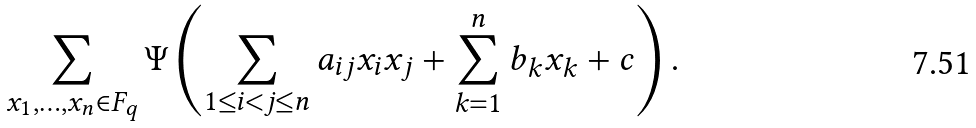<formula> <loc_0><loc_0><loc_500><loc_500>\sum _ { x _ { 1 } , \dots , x _ { n } \in { F } _ { q } } \Psi \left ( \sum _ { 1 \leq i < j \leq n } a _ { i j } x _ { i } x _ { j } + \sum _ { k = 1 } ^ { n } b _ { k } x _ { k } + c \right ) .</formula> 